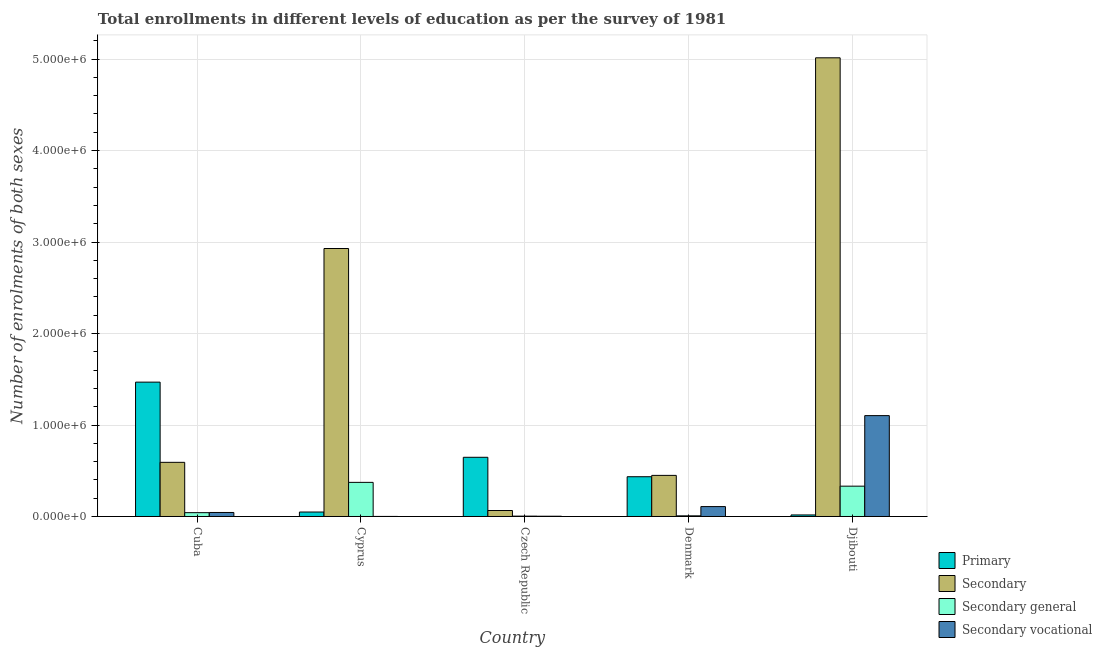How many different coloured bars are there?
Offer a terse response. 4. Are the number of bars per tick equal to the number of legend labels?
Provide a short and direct response. Yes. Are the number of bars on each tick of the X-axis equal?
Give a very brief answer. Yes. How many bars are there on the 1st tick from the left?
Keep it short and to the point. 4. What is the label of the 5th group of bars from the left?
Your answer should be compact. Djibouti. What is the number of enrolments in secondary education in Cuba?
Keep it short and to the point. 5.92e+05. Across all countries, what is the maximum number of enrolments in secondary education?
Your response must be concise. 5.01e+06. Across all countries, what is the minimum number of enrolments in secondary vocational education?
Provide a succinct answer. 570. In which country was the number of enrolments in secondary general education maximum?
Provide a succinct answer. Cyprus. In which country was the number of enrolments in secondary general education minimum?
Offer a terse response. Czech Republic. What is the total number of enrolments in secondary general education in the graph?
Offer a terse response. 7.57e+05. What is the difference between the number of enrolments in secondary education in Cuba and that in Cyprus?
Provide a short and direct response. -2.34e+06. What is the difference between the number of enrolments in secondary education in Cuba and the number of enrolments in primary education in Cyprus?
Offer a very short reply. 5.43e+05. What is the average number of enrolments in secondary vocational education per country?
Keep it short and to the point. 2.52e+05. What is the difference between the number of enrolments in secondary general education and number of enrolments in secondary vocational education in Czech Republic?
Offer a very short reply. 1047. In how many countries, is the number of enrolments in primary education greater than 4000000 ?
Ensure brevity in your answer.  0. What is the ratio of the number of enrolments in secondary general education in Cuba to that in Denmark?
Your answer should be compact. 5.95. Is the difference between the number of enrolments in secondary education in Cuba and Denmark greater than the difference between the number of enrolments in primary education in Cuba and Denmark?
Offer a terse response. No. What is the difference between the highest and the second highest number of enrolments in secondary education?
Keep it short and to the point. 2.08e+06. What is the difference between the highest and the lowest number of enrolments in primary education?
Provide a succinct answer. 1.45e+06. Is it the case that in every country, the sum of the number of enrolments in primary education and number of enrolments in secondary vocational education is greater than the sum of number of enrolments in secondary education and number of enrolments in secondary general education?
Provide a succinct answer. No. What does the 2nd bar from the left in Denmark represents?
Your answer should be compact. Secondary. What does the 2nd bar from the right in Djibouti represents?
Your response must be concise. Secondary general. Are all the bars in the graph horizontal?
Keep it short and to the point. No. Does the graph contain any zero values?
Offer a very short reply. No. What is the title of the graph?
Your answer should be compact. Total enrollments in different levels of education as per the survey of 1981. Does "Other greenhouse gases" appear as one of the legend labels in the graph?
Your response must be concise. No. What is the label or title of the Y-axis?
Offer a terse response. Number of enrolments of both sexes. What is the Number of enrolments of both sexes of Primary in Cuba?
Your answer should be compact. 1.47e+06. What is the Number of enrolments of both sexes in Secondary in Cuba?
Give a very brief answer. 5.92e+05. What is the Number of enrolments of both sexes in Secondary general in Cuba?
Your answer should be compact. 4.18e+04. What is the Number of enrolments of both sexes in Secondary vocational in Cuba?
Give a very brief answer. 4.38e+04. What is the Number of enrolments of both sexes in Primary in Cyprus?
Offer a very short reply. 4.87e+04. What is the Number of enrolments of both sexes of Secondary in Cyprus?
Provide a short and direct response. 2.93e+06. What is the Number of enrolments of both sexes of Secondary general in Cyprus?
Provide a succinct answer. 3.73e+05. What is the Number of enrolments of both sexes of Secondary vocational in Cyprus?
Offer a very short reply. 570. What is the Number of enrolments of both sexes of Primary in Czech Republic?
Your answer should be compact. 6.47e+05. What is the Number of enrolments of both sexes of Secondary in Czech Republic?
Provide a succinct answer. 6.53e+04. What is the Number of enrolments of both sexes of Secondary general in Czech Republic?
Provide a succinct answer. 3812. What is the Number of enrolments of both sexes of Secondary vocational in Czech Republic?
Offer a very short reply. 2765. What is the Number of enrolments of both sexes of Primary in Denmark?
Your answer should be very brief. 4.35e+05. What is the Number of enrolments of both sexes in Secondary in Denmark?
Offer a terse response. 4.49e+05. What is the Number of enrolments of both sexes of Secondary general in Denmark?
Make the answer very short. 7022. What is the Number of enrolments of both sexes of Secondary vocational in Denmark?
Your answer should be compact. 1.08e+05. What is the Number of enrolments of both sexes of Primary in Djibouti?
Your answer should be very brief. 1.68e+04. What is the Number of enrolments of both sexes of Secondary in Djibouti?
Your response must be concise. 5.01e+06. What is the Number of enrolments of both sexes of Secondary general in Djibouti?
Your answer should be very brief. 3.31e+05. What is the Number of enrolments of both sexes of Secondary vocational in Djibouti?
Provide a succinct answer. 1.10e+06. Across all countries, what is the maximum Number of enrolments of both sexes in Primary?
Provide a short and direct response. 1.47e+06. Across all countries, what is the maximum Number of enrolments of both sexes in Secondary?
Provide a short and direct response. 5.01e+06. Across all countries, what is the maximum Number of enrolments of both sexes in Secondary general?
Ensure brevity in your answer.  3.73e+05. Across all countries, what is the maximum Number of enrolments of both sexes of Secondary vocational?
Offer a very short reply. 1.10e+06. Across all countries, what is the minimum Number of enrolments of both sexes in Primary?
Offer a very short reply. 1.68e+04. Across all countries, what is the minimum Number of enrolments of both sexes in Secondary?
Your answer should be compact. 6.53e+04. Across all countries, what is the minimum Number of enrolments of both sexes in Secondary general?
Offer a very short reply. 3812. Across all countries, what is the minimum Number of enrolments of both sexes of Secondary vocational?
Keep it short and to the point. 570. What is the total Number of enrolments of both sexes in Primary in the graph?
Provide a short and direct response. 2.62e+06. What is the total Number of enrolments of both sexes of Secondary in the graph?
Ensure brevity in your answer.  9.05e+06. What is the total Number of enrolments of both sexes of Secondary general in the graph?
Provide a short and direct response. 7.57e+05. What is the total Number of enrolments of both sexes of Secondary vocational in the graph?
Make the answer very short. 1.26e+06. What is the difference between the Number of enrolments of both sexes of Primary in Cuba and that in Cyprus?
Your response must be concise. 1.42e+06. What is the difference between the Number of enrolments of both sexes of Secondary in Cuba and that in Cyprus?
Your answer should be compact. -2.34e+06. What is the difference between the Number of enrolments of both sexes in Secondary general in Cuba and that in Cyprus?
Make the answer very short. -3.31e+05. What is the difference between the Number of enrolments of both sexes in Secondary vocational in Cuba and that in Cyprus?
Make the answer very short. 4.33e+04. What is the difference between the Number of enrolments of both sexes of Primary in Cuba and that in Czech Republic?
Your answer should be very brief. 8.22e+05. What is the difference between the Number of enrolments of both sexes in Secondary in Cuba and that in Czech Republic?
Provide a succinct answer. 5.27e+05. What is the difference between the Number of enrolments of both sexes of Secondary general in Cuba and that in Czech Republic?
Offer a terse response. 3.80e+04. What is the difference between the Number of enrolments of both sexes of Secondary vocational in Cuba and that in Czech Republic?
Make the answer very short. 4.11e+04. What is the difference between the Number of enrolments of both sexes in Primary in Cuba and that in Denmark?
Provide a short and direct response. 1.03e+06. What is the difference between the Number of enrolments of both sexes in Secondary in Cuba and that in Denmark?
Ensure brevity in your answer.  1.43e+05. What is the difference between the Number of enrolments of both sexes of Secondary general in Cuba and that in Denmark?
Provide a succinct answer. 3.48e+04. What is the difference between the Number of enrolments of both sexes in Secondary vocational in Cuba and that in Denmark?
Your response must be concise. -6.44e+04. What is the difference between the Number of enrolments of both sexes of Primary in Cuba and that in Djibouti?
Offer a very short reply. 1.45e+06. What is the difference between the Number of enrolments of both sexes in Secondary in Cuba and that in Djibouti?
Your answer should be compact. -4.42e+06. What is the difference between the Number of enrolments of both sexes of Secondary general in Cuba and that in Djibouti?
Keep it short and to the point. -2.90e+05. What is the difference between the Number of enrolments of both sexes of Secondary vocational in Cuba and that in Djibouti?
Ensure brevity in your answer.  -1.06e+06. What is the difference between the Number of enrolments of both sexes in Primary in Cyprus and that in Czech Republic?
Keep it short and to the point. -5.98e+05. What is the difference between the Number of enrolments of both sexes in Secondary in Cyprus and that in Czech Republic?
Keep it short and to the point. 2.86e+06. What is the difference between the Number of enrolments of both sexes of Secondary general in Cyprus and that in Czech Republic?
Your answer should be very brief. 3.69e+05. What is the difference between the Number of enrolments of both sexes of Secondary vocational in Cyprus and that in Czech Republic?
Your answer should be compact. -2195. What is the difference between the Number of enrolments of both sexes in Primary in Cyprus and that in Denmark?
Provide a short and direct response. -3.86e+05. What is the difference between the Number of enrolments of both sexes in Secondary in Cyprus and that in Denmark?
Offer a terse response. 2.48e+06. What is the difference between the Number of enrolments of both sexes of Secondary general in Cyprus and that in Denmark?
Keep it short and to the point. 3.66e+05. What is the difference between the Number of enrolments of both sexes in Secondary vocational in Cyprus and that in Denmark?
Make the answer very short. -1.08e+05. What is the difference between the Number of enrolments of both sexes in Primary in Cyprus and that in Djibouti?
Provide a short and direct response. 3.19e+04. What is the difference between the Number of enrolments of both sexes in Secondary in Cyprus and that in Djibouti?
Offer a terse response. -2.08e+06. What is the difference between the Number of enrolments of both sexes in Secondary general in Cyprus and that in Djibouti?
Keep it short and to the point. 4.15e+04. What is the difference between the Number of enrolments of both sexes in Secondary vocational in Cyprus and that in Djibouti?
Provide a succinct answer. -1.10e+06. What is the difference between the Number of enrolments of both sexes of Primary in Czech Republic and that in Denmark?
Ensure brevity in your answer.  2.12e+05. What is the difference between the Number of enrolments of both sexes of Secondary in Czech Republic and that in Denmark?
Provide a short and direct response. -3.84e+05. What is the difference between the Number of enrolments of both sexes of Secondary general in Czech Republic and that in Denmark?
Make the answer very short. -3210. What is the difference between the Number of enrolments of both sexes in Secondary vocational in Czech Republic and that in Denmark?
Ensure brevity in your answer.  -1.06e+05. What is the difference between the Number of enrolments of both sexes of Primary in Czech Republic and that in Djibouti?
Offer a terse response. 6.30e+05. What is the difference between the Number of enrolments of both sexes of Secondary in Czech Republic and that in Djibouti?
Make the answer very short. -4.95e+06. What is the difference between the Number of enrolments of both sexes of Secondary general in Czech Republic and that in Djibouti?
Give a very brief answer. -3.28e+05. What is the difference between the Number of enrolments of both sexes in Secondary vocational in Czech Republic and that in Djibouti?
Make the answer very short. -1.10e+06. What is the difference between the Number of enrolments of both sexes of Primary in Denmark and that in Djibouti?
Keep it short and to the point. 4.18e+05. What is the difference between the Number of enrolments of both sexes in Secondary in Denmark and that in Djibouti?
Your response must be concise. -4.56e+06. What is the difference between the Number of enrolments of both sexes of Secondary general in Denmark and that in Djibouti?
Provide a succinct answer. -3.24e+05. What is the difference between the Number of enrolments of both sexes of Secondary vocational in Denmark and that in Djibouti?
Ensure brevity in your answer.  -9.94e+05. What is the difference between the Number of enrolments of both sexes of Primary in Cuba and the Number of enrolments of both sexes of Secondary in Cyprus?
Offer a very short reply. -1.46e+06. What is the difference between the Number of enrolments of both sexes in Primary in Cuba and the Number of enrolments of both sexes in Secondary general in Cyprus?
Provide a short and direct response. 1.10e+06. What is the difference between the Number of enrolments of both sexes in Primary in Cuba and the Number of enrolments of both sexes in Secondary vocational in Cyprus?
Provide a succinct answer. 1.47e+06. What is the difference between the Number of enrolments of both sexes of Secondary in Cuba and the Number of enrolments of both sexes of Secondary general in Cyprus?
Keep it short and to the point. 2.19e+05. What is the difference between the Number of enrolments of both sexes in Secondary in Cuba and the Number of enrolments of both sexes in Secondary vocational in Cyprus?
Provide a short and direct response. 5.91e+05. What is the difference between the Number of enrolments of both sexes in Secondary general in Cuba and the Number of enrolments of both sexes in Secondary vocational in Cyprus?
Provide a short and direct response. 4.12e+04. What is the difference between the Number of enrolments of both sexes of Primary in Cuba and the Number of enrolments of both sexes of Secondary in Czech Republic?
Give a very brief answer. 1.40e+06. What is the difference between the Number of enrolments of both sexes in Primary in Cuba and the Number of enrolments of both sexes in Secondary general in Czech Republic?
Offer a terse response. 1.46e+06. What is the difference between the Number of enrolments of both sexes in Primary in Cuba and the Number of enrolments of both sexes in Secondary vocational in Czech Republic?
Give a very brief answer. 1.47e+06. What is the difference between the Number of enrolments of both sexes in Secondary in Cuba and the Number of enrolments of both sexes in Secondary general in Czech Republic?
Your answer should be very brief. 5.88e+05. What is the difference between the Number of enrolments of both sexes in Secondary in Cuba and the Number of enrolments of both sexes in Secondary vocational in Czech Republic?
Make the answer very short. 5.89e+05. What is the difference between the Number of enrolments of both sexes in Secondary general in Cuba and the Number of enrolments of both sexes in Secondary vocational in Czech Republic?
Provide a succinct answer. 3.90e+04. What is the difference between the Number of enrolments of both sexes in Primary in Cuba and the Number of enrolments of both sexes in Secondary in Denmark?
Provide a short and direct response. 1.02e+06. What is the difference between the Number of enrolments of both sexes in Primary in Cuba and the Number of enrolments of both sexes in Secondary general in Denmark?
Offer a very short reply. 1.46e+06. What is the difference between the Number of enrolments of both sexes of Primary in Cuba and the Number of enrolments of both sexes of Secondary vocational in Denmark?
Ensure brevity in your answer.  1.36e+06. What is the difference between the Number of enrolments of both sexes of Secondary in Cuba and the Number of enrolments of both sexes of Secondary general in Denmark?
Provide a short and direct response. 5.85e+05. What is the difference between the Number of enrolments of both sexes of Secondary in Cuba and the Number of enrolments of both sexes of Secondary vocational in Denmark?
Keep it short and to the point. 4.84e+05. What is the difference between the Number of enrolments of both sexes of Secondary general in Cuba and the Number of enrolments of both sexes of Secondary vocational in Denmark?
Your answer should be very brief. -6.65e+04. What is the difference between the Number of enrolments of both sexes in Primary in Cuba and the Number of enrolments of both sexes in Secondary in Djibouti?
Provide a short and direct response. -3.55e+06. What is the difference between the Number of enrolments of both sexes in Primary in Cuba and the Number of enrolments of both sexes in Secondary general in Djibouti?
Offer a terse response. 1.14e+06. What is the difference between the Number of enrolments of both sexes in Primary in Cuba and the Number of enrolments of both sexes in Secondary vocational in Djibouti?
Your response must be concise. 3.66e+05. What is the difference between the Number of enrolments of both sexes in Secondary in Cuba and the Number of enrolments of both sexes in Secondary general in Djibouti?
Your answer should be very brief. 2.60e+05. What is the difference between the Number of enrolments of both sexes in Secondary in Cuba and the Number of enrolments of both sexes in Secondary vocational in Djibouti?
Your answer should be compact. -5.11e+05. What is the difference between the Number of enrolments of both sexes in Secondary general in Cuba and the Number of enrolments of both sexes in Secondary vocational in Djibouti?
Give a very brief answer. -1.06e+06. What is the difference between the Number of enrolments of both sexes of Primary in Cyprus and the Number of enrolments of both sexes of Secondary in Czech Republic?
Give a very brief answer. -1.66e+04. What is the difference between the Number of enrolments of both sexes in Primary in Cyprus and the Number of enrolments of both sexes in Secondary general in Czech Republic?
Provide a short and direct response. 4.49e+04. What is the difference between the Number of enrolments of both sexes of Primary in Cyprus and the Number of enrolments of both sexes of Secondary vocational in Czech Republic?
Offer a very short reply. 4.59e+04. What is the difference between the Number of enrolments of both sexes in Secondary in Cyprus and the Number of enrolments of both sexes in Secondary general in Czech Republic?
Provide a succinct answer. 2.93e+06. What is the difference between the Number of enrolments of both sexes of Secondary in Cyprus and the Number of enrolments of both sexes of Secondary vocational in Czech Republic?
Make the answer very short. 2.93e+06. What is the difference between the Number of enrolments of both sexes in Secondary general in Cyprus and the Number of enrolments of both sexes in Secondary vocational in Czech Republic?
Your answer should be compact. 3.70e+05. What is the difference between the Number of enrolments of both sexes in Primary in Cyprus and the Number of enrolments of both sexes in Secondary in Denmark?
Ensure brevity in your answer.  -4.01e+05. What is the difference between the Number of enrolments of both sexes in Primary in Cyprus and the Number of enrolments of both sexes in Secondary general in Denmark?
Make the answer very short. 4.17e+04. What is the difference between the Number of enrolments of both sexes in Primary in Cyprus and the Number of enrolments of both sexes in Secondary vocational in Denmark?
Your answer should be compact. -5.96e+04. What is the difference between the Number of enrolments of both sexes in Secondary in Cyprus and the Number of enrolments of both sexes in Secondary general in Denmark?
Offer a terse response. 2.92e+06. What is the difference between the Number of enrolments of both sexes in Secondary in Cyprus and the Number of enrolments of both sexes in Secondary vocational in Denmark?
Your answer should be compact. 2.82e+06. What is the difference between the Number of enrolments of both sexes of Secondary general in Cyprus and the Number of enrolments of both sexes of Secondary vocational in Denmark?
Your answer should be compact. 2.65e+05. What is the difference between the Number of enrolments of both sexes in Primary in Cyprus and the Number of enrolments of both sexes in Secondary in Djibouti?
Your answer should be very brief. -4.96e+06. What is the difference between the Number of enrolments of both sexes in Primary in Cyprus and the Number of enrolments of both sexes in Secondary general in Djibouti?
Offer a very short reply. -2.83e+05. What is the difference between the Number of enrolments of both sexes in Primary in Cyprus and the Number of enrolments of both sexes in Secondary vocational in Djibouti?
Your answer should be very brief. -1.05e+06. What is the difference between the Number of enrolments of both sexes of Secondary in Cyprus and the Number of enrolments of both sexes of Secondary general in Djibouti?
Offer a terse response. 2.60e+06. What is the difference between the Number of enrolments of both sexes in Secondary in Cyprus and the Number of enrolments of both sexes in Secondary vocational in Djibouti?
Offer a terse response. 1.83e+06. What is the difference between the Number of enrolments of both sexes in Secondary general in Cyprus and the Number of enrolments of both sexes in Secondary vocational in Djibouti?
Your response must be concise. -7.30e+05. What is the difference between the Number of enrolments of both sexes of Primary in Czech Republic and the Number of enrolments of both sexes of Secondary in Denmark?
Offer a very short reply. 1.98e+05. What is the difference between the Number of enrolments of both sexes of Primary in Czech Republic and the Number of enrolments of both sexes of Secondary general in Denmark?
Your answer should be compact. 6.40e+05. What is the difference between the Number of enrolments of both sexes of Primary in Czech Republic and the Number of enrolments of both sexes of Secondary vocational in Denmark?
Your answer should be compact. 5.39e+05. What is the difference between the Number of enrolments of both sexes of Secondary in Czech Republic and the Number of enrolments of both sexes of Secondary general in Denmark?
Offer a very short reply. 5.82e+04. What is the difference between the Number of enrolments of both sexes of Secondary in Czech Republic and the Number of enrolments of both sexes of Secondary vocational in Denmark?
Make the answer very short. -4.30e+04. What is the difference between the Number of enrolments of both sexes in Secondary general in Czech Republic and the Number of enrolments of both sexes in Secondary vocational in Denmark?
Give a very brief answer. -1.04e+05. What is the difference between the Number of enrolments of both sexes in Primary in Czech Republic and the Number of enrolments of both sexes in Secondary in Djibouti?
Your response must be concise. -4.37e+06. What is the difference between the Number of enrolments of both sexes in Primary in Czech Republic and the Number of enrolments of both sexes in Secondary general in Djibouti?
Provide a succinct answer. 3.16e+05. What is the difference between the Number of enrolments of both sexes in Primary in Czech Republic and the Number of enrolments of both sexes in Secondary vocational in Djibouti?
Ensure brevity in your answer.  -4.56e+05. What is the difference between the Number of enrolments of both sexes of Secondary in Czech Republic and the Number of enrolments of both sexes of Secondary general in Djibouti?
Your response must be concise. -2.66e+05. What is the difference between the Number of enrolments of both sexes in Secondary in Czech Republic and the Number of enrolments of both sexes in Secondary vocational in Djibouti?
Ensure brevity in your answer.  -1.04e+06. What is the difference between the Number of enrolments of both sexes in Secondary general in Czech Republic and the Number of enrolments of both sexes in Secondary vocational in Djibouti?
Your answer should be very brief. -1.10e+06. What is the difference between the Number of enrolments of both sexes in Primary in Denmark and the Number of enrolments of both sexes in Secondary in Djibouti?
Keep it short and to the point. -4.58e+06. What is the difference between the Number of enrolments of both sexes in Primary in Denmark and the Number of enrolments of both sexes in Secondary general in Djibouti?
Your response must be concise. 1.03e+05. What is the difference between the Number of enrolments of both sexes in Primary in Denmark and the Number of enrolments of both sexes in Secondary vocational in Djibouti?
Provide a short and direct response. -6.68e+05. What is the difference between the Number of enrolments of both sexes in Secondary in Denmark and the Number of enrolments of both sexes in Secondary general in Djibouti?
Your answer should be compact. 1.18e+05. What is the difference between the Number of enrolments of both sexes in Secondary in Denmark and the Number of enrolments of both sexes in Secondary vocational in Djibouti?
Make the answer very short. -6.53e+05. What is the difference between the Number of enrolments of both sexes of Secondary general in Denmark and the Number of enrolments of both sexes of Secondary vocational in Djibouti?
Keep it short and to the point. -1.10e+06. What is the average Number of enrolments of both sexes of Primary per country?
Make the answer very short. 5.23e+05. What is the average Number of enrolments of both sexes of Secondary per country?
Keep it short and to the point. 1.81e+06. What is the average Number of enrolments of both sexes of Secondary general per country?
Your response must be concise. 1.51e+05. What is the average Number of enrolments of both sexes of Secondary vocational per country?
Make the answer very short. 2.52e+05. What is the difference between the Number of enrolments of both sexes of Primary and Number of enrolments of both sexes of Secondary in Cuba?
Provide a short and direct response. 8.77e+05. What is the difference between the Number of enrolments of both sexes in Primary and Number of enrolments of both sexes in Secondary general in Cuba?
Offer a terse response. 1.43e+06. What is the difference between the Number of enrolments of both sexes of Primary and Number of enrolments of both sexes of Secondary vocational in Cuba?
Provide a short and direct response. 1.42e+06. What is the difference between the Number of enrolments of both sexes in Secondary and Number of enrolments of both sexes in Secondary general in Cuba?
Offer a very short reply. 5.50e+05. What is the difference between the Number of enrolments of both sexes of Secondary and Number of enrolments of both sexes of Secondary vocational in Cuba?
Offer a terse response. 5.48e+05. What is the difference between the Number of enrolments of both sexes in Secondary general and Number of enrolments of both sexes in Secondary vocational in Cuba?
Provide a short and direct response. -2047. What is the difference between the Number of enrolments of both sexes in Primary and Number of enrolments of both sexes in Secondary in Cyprus?
Keep it short and to the point. -2.88e+06. What is the difference between the Number of enrolments of both sexes of Primary and Number of enrolments of both sexes of Secondary general in Cyprus?
Make the answer very short. -3.24e+05. What is the difference between the Number of enrolments of both sexes of Primary and Number of enrolments of both sexes of Secondary vocational in Cyprus?
Your answer should be very brief. 4.81e+04. What is the difference between the Number of enrolments of both sexes of Secondary and Number of enrolments of both sexes of Secondary general in Cyprus?
Ensure brevity in your answer.  2.56e+06. What is the difference between the Number of enrolments of both sexes of Secondary and Number of enrolments of both sexes of Secondary vocational in Cyprus?
Provide a short and direct response. 2.93e+06. What is the difference between the Number of enrolments of both sexes of Secondary general and Number of enrolments of both sexes of Secondary vocational in Cyprus?
Your answer should be compact. 3.72e+05. What is the difference between the Number of enrolments of both sexes of Primary and Number of enrolments of both sexes of Secondary in Czech Republic?
Provide a succinct answer. 5.82e+05. What is the difference between the Number of enrolments of both sexes in Primary and Number of enrolments of both sexes in Secondary general in Czech Republic?
Your answer should be compact. 6.43e+05. What is the difference between the Number of enrolments of both sexes in Primary and Number of enrolments of both sexes in Secondary vocational in Czech Republic?
Provide a succinct answer. 6.44e+05. What is the difference between the Number of enrolments of both sexes of Secondary and Number of enrolments of both sexes of Secondary general in Czech Republic?
Keep it short and to the point. 6.14e+04. What is the difference between the Number of enrolments of both sexes in Secondary and Number of enrolments of both sexes in Secondary vocational in Czech Republic?
Your answer should be very brief. 6.25e+04. What is the difference between the Number of enrolments of both sexes of Secondary general and Number of enrolments of both sexes of Secondary vocational in Czech Republic?
Keep it short and to the point. 1047. What is the difference between the Number of enrolments of both sexes of Primary and Number of enrolments of both sexes of Secondary in Denmark?
Your answer should be very brief. -1.47e+04. What is the difference between the Number of enrolments of both sexes in Primary and Number of enrolments of both sexes in Secondary general in Denmark?
Offer a terse response. 4.28e+05. What is the difference between the Number of enrolments of both sexes of Primary and Number of enrolments of both sexes of Secondary vocational in Denmark?
Offer a very short reply. 3.26e+05. What is the difference between the Number of enrolments of both sexes of Secondary and Number of enrolments of both sexes of Secondary general in Denmark?
Offer a very short reply. 4.42e+05. What is the difference between the Number of enrolments of both sexes in Secondary and Number of enrolments of both sexes in Secondary vocational in Denmark?
Provide a short and direct response. 3.41e+05. What is the difference between the Number of enrolments of both sexes in Secondary general and Number of enrolments of both sexes in Secondary vocational in Denmark?
Offer a very short reply. -1.01e+05. What is the difference between the Number of enrolments of both sexes in Primary and Number of enrolments of both sexes in Secondary in Djibouti?
Make the answer very short. -5.00e+06. What is the difference between the Number of enrolments of both sexes of Primary and Number of enrolments of both sexes of Secondary general in Djibouti?
Ensure brevity in your answer.  -3.15e+05. What is the difference between the Number of enrolments of both sexes of Primary and Number of enrolments of both sexes of Secondary vocational in Djibouti?
Make the answer very short. -1.09e+06. What is the difference between the Number of enrolments of both sexes of Secondary and Number of enrolments of both sexes of Secondary general in Djibouti?
Your answer should be very brief. 4.68e+06. What is the difference between the Number of enrolments of both sexes in Secondary and Number of enrolments of both sexes in Secondary vocational in Djibouti?
Your response must be concise. 3.91e+06. What is the difference between the Number of enrolments of both sexes of Secondary general and Number of enrolments of both sexes of Secondary vocational in Djibouti?
Make the answer very short. -7.71e+05. What is the ratio of the Number of enrolments of both sexes in Primary in Cuba to that in Cyprus?
Ensure brevity in your answer.  30.15. What is the ratio of the Number of enrolments of both sexes of Secondary in Cuba to that in Cyprus?
Offer a terse response. 0.2. What is the ratio of the Number of enrolments of both sexes of Secondary general in Cuba to that in Cyprus?
Make the answer very short. 0.11. What is the ratio of the Number of enrolments of both sexes of Secondary vocational in Cuba to that in Cyprus?
Your answer should be very brief. 76.91. What is the ratio of the Number of enrolments of both sexes of Primary in Cuba to that in Czech Republic?
Your answer should be compact. 2.27. What is the ratio of the Number of enrolments of both sexes in Secondary in Cuba to that in Czech Republic?
Your response must be concise. 9.07. What is the ratio of the Number of enrolments of both sexes of Secondary general in Cuba to that in Czech Republic?
Provide a short and direct response. 10.96. What is the ratio of the Number of enrolments of both sexes of Secondary vocational in Cuba to that in Czech Republic?
Ensure brevity in your answer.  15.86. What is the ratio of the Number of enrolments of both sexes in Primary in Cuba to that in Denmark?
Give a very brief answer. 3.38. What is the ratio of the Number of enrolments of both sexes in Secondary in Cuba to that in Denmark?
Your response must be concise. 1.32. What is the ratio of the Number of enrolments of both sexes of Secondary general in Cuba to that in Denmark?
Keep it short and to the point. 5.95. What is the ratio of the Number of enrolments of both sexes of Secondary vocational in Cuba to that in Denmark?
Your response must be concise. 0.4. What is the ratio of the Number of enrolments of both sexes in Primary in Cuba to that in Djibouti?
Offer a very short reply. 87.2. What is the ratio of the Number of enrolments of both sexes of Secondary in Cuba to that in Djibouti?
Make the answer very short. 0.12. What is the ratio of the Number of enrolments of both sexes of Secondary general in Cuba to that in Djibouti?
Provide a short and direct response. 0.13. What is the ratio of the Number of enrolments of both sexes of Secondary vocational in Cuba to that in Djibouti?
Provide a short and direct response. 0.04. What is the ratio of the Number of enrolments of both sexes in Primary in Cyprus to that in Czech Republic?
Your response must be concise. 0.08. What is the ratio of the Number of enrolments of both sexes in Secondary in Cyprus to that in Czech Republic?
Keep it short and to the point. 44.89. What is the ratio of the Number of enrolments of both sexes of Secondary general in Cyprus to that in Czech Republic?
Offer a terse response. 97.84. What is the ratio of the Number of enrolments of both sexes in Secondary vocational in Cyprus to that in Czech Republic?
Offer a terse response. 0.21. What is the ratio of the Number of enrolments of both sexes in Primary in Cyprus to that in Denmark?
Offer a very short reply. 0.11. What is the ratio of the Number of enrolments of both sexes of Secondary in Cyprus to that in Denmark?
Ensure brevity in your answer.  6.52. What is the ratio of the Number of enrolments of both sexes in Secondary general in Cyprus to that in Denmark?
Provide a succinct answer. 53.11. What is the ratio of the Number of enrolments of both sexes in Secondary vocational in Cyprus to that in Denmark?
Your response must be concise. 0.01. What is the ratio of the Number of enrolments of both sexes of Primary in Cyprus to that in Djibouti?
Your answer should be very brief. 2.89. What is the ratio of the Number of enrolments of both sexes in Secondary in Cyprus to that in Djibouti?
Offer a terse response. 0.58. What is the ratio of the Number of enrolments of both sexes in Secondary general in Cyprus to that in Djibouti?
Give a very brief answer. 1.13. What is the ratio of the Number of enrolments of both sexes of Primary in Czech Republic to that in Denmark?
Your answer should be very brief. 1.49. What is the ratio of the Number of enrolments of both sexes in Secondary in Czech Republic to that in Denmark?
Offer a terse response. 0.15. What is the ratio of the Number of enrolments of both sexes of Secondary general in Czech Republic to that in Denmark?
Offer a very short reply. 0.54. What is the ratio of the Number of enrolments of both sexes in Secondary vocational in Czech Republic to that in Denmark?
Your answer should be very brief. 0.03. What is the ratio of the Number of enrolments of both sexes of Primary in Czech Republic to that in Djibouti?
Offer a terse response. 38.42. What is the ratio of the Number of enrolments of both sexes of Secondary in Czech Republic to that in Djibouti?
Ensure brevity in your answer.  0.01. What is the ratio of the Number of enrolments of both sexes in Secondary general in Czech Republic to that in Djibouti?
Provide a short and direct response. 0.01. What is the ratio of the Number of enrolments of both sexes of Secondary vocational in Czech Republic to that in Djibouti?
Your response must be concise. 0. What is the ratio of the Number of enrolments of both sexes in Primary in Denmark to that in Djibouti?
Give a very brief answer. 25.81. What is the ratio of the Number of enrolments of both sexes in Secondary in Denmark to that in Djibouti?
Your answer should be compact. 0.09. What is the ratio of the Number of enrolments of both sexes in Secondary general in Denmark to that in Djibouti?
Provide a succinct answer. 0.02. What is the ratio of the Number of enrolments of both sexes in Secondary vocational in Denmark to that in Djibouti?
Offer a terse response. 0.1. What is the difference between the highest and the second highest Number of enrolments of both sexes of Primary?
Make the answer very short. 8.22e+05. What is the difference between the highest and the second highest Number of enrolments of both sexes of Secondary?
Provide a succinct answer. 2.08e+06. What is the difference between the highest and the second highest Number of enrolments of both sexes of Secondary general?
Your response must be concise. 4.15e+04. What is the difference between the highest and the second highest Number of enrolments of both sexes in Secondary vocational?
Your answer should be compact. 9.94e+05. What is the difference between the highest and the lowest Number of enrolments of both sexes of Primary?
Give a very brief answer. 1.45e+06. What is the difference between the highest and the lowest Number of enrolments of both sexes of Secondary?
Ensure brevity in your answer.  4.95e+06. What is the difference between the highest and the lowest Number of enrolments of both sexes of Secondary general?
Your answer should be compact. 3.69e+05. What is the difference between the highest and the lowest Number of enrolments of both sexes of Secondary vocational?
Make the answer very short. 1.10e+06. 